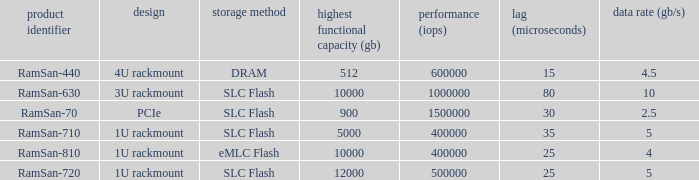What is the shape distortion for the range frequency of 10? 3U rackmount. 